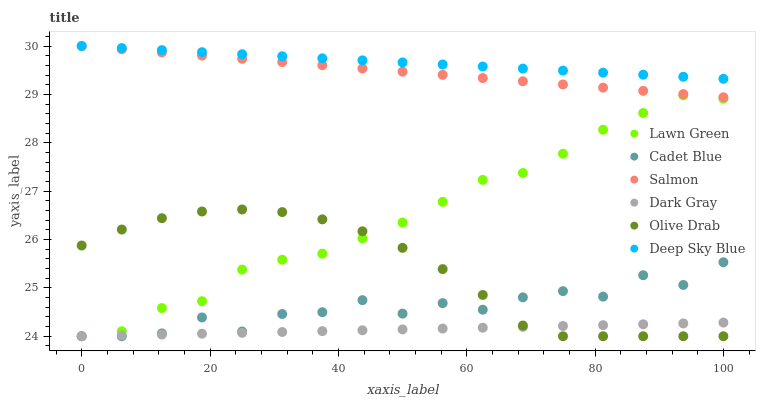Does Dark Gray have the minimum area under the curve?
Answer yes or no. Yes. Does Deep Sky Blue have the maximum area under the curve?
Answer yes or no. Yes. Does Cadet Blue have the minimum area under the curve?
Answer yes or no. No. Does Cadet Blue have the maximum area under the curve?
Answer yes or no. No. Is Dark Gray the smoothest?
Answer yes or no. Yes. Is Cadet Blue the roughest?
Answer yes or no. Yes. Is Salmon the smoothest?
Answer yes or no. No. Is Salmon the roughest?
Answer yes or no. No. Does Lawn Green have the lowest value?
Answer yes or no. Yes. Does Salmon have the lowest value?
Answer yes or no. No. Does Deep Sky Blue have the highest value?
Answer yes or no. Yes. Does Cadet Blue have the highest value?
Answer yes or no. No. Is Cadet Blue less than Deep Sky Blue?
Answer yes or no. Yes. Is Salmon greater than Olive Drab?
Answer yes or no. Yes. Does Salmon intersect Deep Sky Blue?
Answer yes or no. Yes. Is Salmon less than Deep Sky Blue?
Answer yes or no. No. Is Salmon greater than Deep Sky Blue?
Answer yes or no. No. Does Cadet Blue intersect Deep Sky Blue?
Answer yes or no. No. 